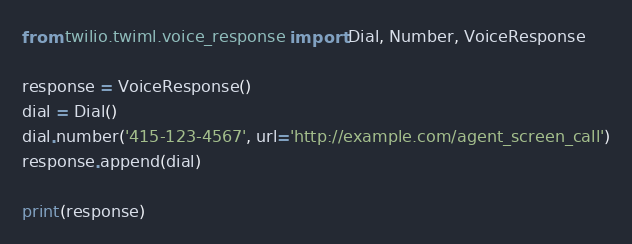<code> <loc_0><loc_0><loc_500><loc_500><_Python_>from twilio.twiml.voice_response import Dial, Number, VoiceResponse

response = VoiceResponse()
dial = Dial()
dial.number('415-123-4567', url='http://example.com/agent_screen_call')
response.append(dial)

print(response)
</code> 